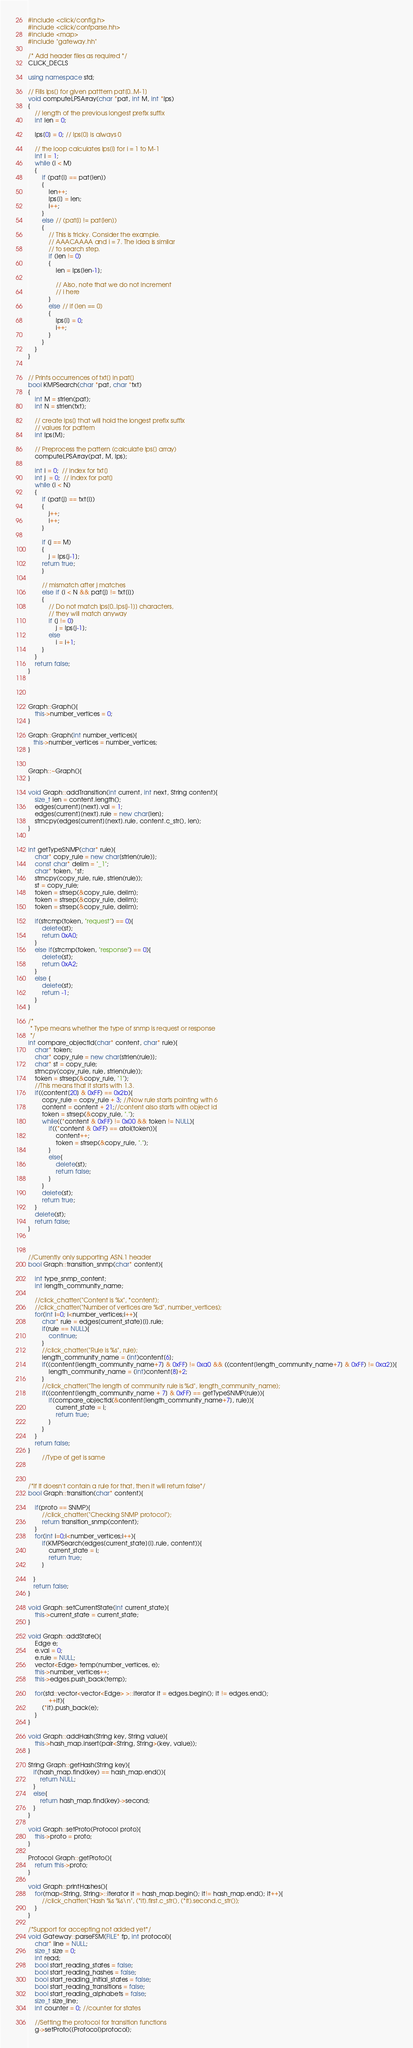<code> <loc_0><loc_0><loc_500><loc_500><_C++_>#include <click/config.h>
#include <click/confparse.hh>
#include <map>
#include "gateway.hh"

/* Add header files as required */
CLICK_DECLS

using namespace std;

// Fills lps[] for given patttern pat[0..M-1]
void computeLPSArray(char *pat, int M, int *lps)
{
    // length of the previous longest prefix suffix
    int len = 0;
 
    lps[0] = 0; // lps[0] is always 0
 
    // the loop calculates lps[i] for i = 1 to M-1
    int i = 1;
    while (i < M)
    {
        if (pat[i] == pat[len])
        {
            len++;
            lps[i] = len;
            i++;
        }
        else // (pat[i] != pat[len])
        {
            // This is tricky. Consider the example.
            // AAACAAAA and i = 7. The idea is similar 
            // to search step.
            if (len != 0)
            {
                len = lps[len-1];
 
                // Also, note that we do not increment
                // i here
            }
            else // if (len == 0)
            {
                lps[i] = 0;
                i++;
            }
        }
    }
}


// Prints occurrences of txt[] in pat[]
bool KMPSearch(char *pat, char *txt)
{
    int M = strlen(pat);
    int N = strlen(txt);
 
    // create lps[] that will hold the longest prefix suffix
    // values for pattern
    int lps[M];
 
    // Preprocess the pattern (calculate lps[] array)
    computeLPSArray(pat, M, lps);
 
    int i = 0;  // index for txt[]
    int j  = 0;  // index for pat[]
    while (i < N)
    {
        if (pat[j] == txt[i])
        {
            j++;
            i++;
        }
 
        if (j == M)
        {
            j = lps[j-1];
	    return true;
        }
 
        // mismatch after j matches
        else if (i < N && pat[j] != txt[i])
        {
            // Do not match lps[0..lps[j-1]] characters,
            // they will match anyway
            if (j != 0)
                j = lps[j-1];
            else
                i = i+1;
        }
    }
    return false;
}
 



Graph::Graph(){
    this->number_vertices = 0;
}

Graph::Graph(int number_vertices){
   this->number_vertices = number_vertices;
}


Graph::~Graph(){
}

void Graph::addTransition(int current, int next, String content){
    size_t len = content.length();
    edges[current][next].val = 1;
    edges[current][next].rule = new char[len];
    strncpy(edges[current][next].rule, content.c_str(), len);
}


int getTypeSNMP(char* rule){
    char* copy_rule = new char[strlen(rule)];
    const char* delim = "_1";
    char* token, *st;
    strncpy(copy_rule, rule, strlen(rule));
    st = copy_rule;
    token = strsep(&copy_rule, delim);
    token = strsep(&copy_rule, delim);
    token = strsep(&copy_rule, delim);

    if(strcmp(token, "request") == 0){
        delete(st);
        return 0xA0;
    }
    else if(strcmp(token, "response") == 0){
        delete(st);
        return 0xA2;
    }
    else {
        delete(st);
        return -1;
    }
}

/*
 * Type means whether the type of snmp is request or response
 */
int compare_objectId(char* content, char* rule){
    char* token;
    char* copy_rule = new char[strlen(rule)];
    char* st = copy_rule;
    strncpy(copy_rule, rule, strlen(rule));
    token = strsep(&copy_rule, "1");
    //This means that it starts with 1.3.
    if((content[20] & 0xFF) == 0x2b){
        copy_rule = copy_rule + 3; //Now rule starts pointing with 6
        content = content + 21;//content also starts with object id
        token = strsep(&copy_rule, ".");
        while((*content & 0xFF) != 0x00 && token != NULL){
            if((*content & 0xFF) == atoi(token)){
                content++;
                token = strsep(&copy_rule, ".");
            }
            else{
                delete(st);
                return false;
            }
        }
        delete(st);
        return true;
    }
    delete(st);
    return false;
}



//Currently only supporting ASN.1 header
bool Graph::transition_snmp(char* content){
    
    int type_snmp_content;    
    int length_community_name;

    //click_chatter("Content is %x", *content);
    //click_chatter("Number of vertices are %d", number_vertices);
    for(int i=0; i<number_vertices;i++){
        char* rule = edges[current_state][i].rule;
        if(rule == NULL){
            continue;
        }
        //click_chatter("Rule is %s", rule);
        length_community_name = (int)content[6];
        if((content[length_community_name+7] & 0xFF) != 0xa0 && ((content[length_community_name+7] & 0xFF) != 0xa2)){
            length_community_name = (int)content[8]+2;
        }
        //click_chatter("The length of community rule is %d", length_community_name);
        if((content[length_community_name + 7] & 0xFF) == getTypeSNMP(rule)){
            if(compare_objectId(&content[length_community_name+7], rule)){
                current_state = i;
                return true;
            }
        }
    }
    return false;
}
        //Type of get is same

        

/*If it doesn't contain a rule for that, then it will return false*/
bool Graph::transition(char* content){
   
    if(proto == SNMP){
        //click_chatter("Checking SNMP protocol");
        return transition_snmp(content);
    }        
    for(int i=0;i<number_vertices;i++){
        if(KMPSearch(edges[current_state][i].rule, content)){
            current_state = i;
            return true;
        }

   }
   return false;
}

void Graph::setCurrentState(int current_state){
    this->current_state = current_state;
}

void Graph::addState(){
    Edge e;
    e.val = 0;
    e.rule = NULL;
    vector<Edge> temp(number_vertices, e);
    this->number_vertices++;
    this->edges.push_back(temp);
    
    for(std::vector<vector<Edge> >::iterator it = edges.begin(); it != edges.end();
            ++it){
        (*it).push_back(e);
    }
}

void Graph::addHash(String key, String value){
    this->hash_map.insert(pair<String, String>(key, value));
}

String Graph::getHash(String key){
   if(hash_map.find(key) == hash_map.end()){
       return NULL;
   }
   else{
       return hash_map.find(key)->second; 
   }
}

void Graph::setProto(Protocol proto){
    this->proto = proto;
}

Protocol Graph::getProto(){
    return this->proto;
}

void Graph::printHashes(){
    for(map<String, String>::iterator it = hash_map.begin(); it!= hash_map.end(); it++){
        //click_chatter("Hash %s %s\n", (*it).first.c_str(), (*it).second.c_str());
    }
}

/*Support for accepting not added yet*/
void Gateway::parseFSM(FILE* fp, int protocol){
    char* line = NULL;
    size_t size = 0;
    int read;
    bool start_reading_states = false;
    bool start_reading_hashes = false;
    bool start_reading_initial_states = false;
    bool start_reading_transitions = false;
    bool start_reading_alphabets = false;
    size_t size_line;
    int counter = 0; //counter for states

    //Setting the protocol for transition functions
    g->setProto((Protocol)protocol);
</code> 